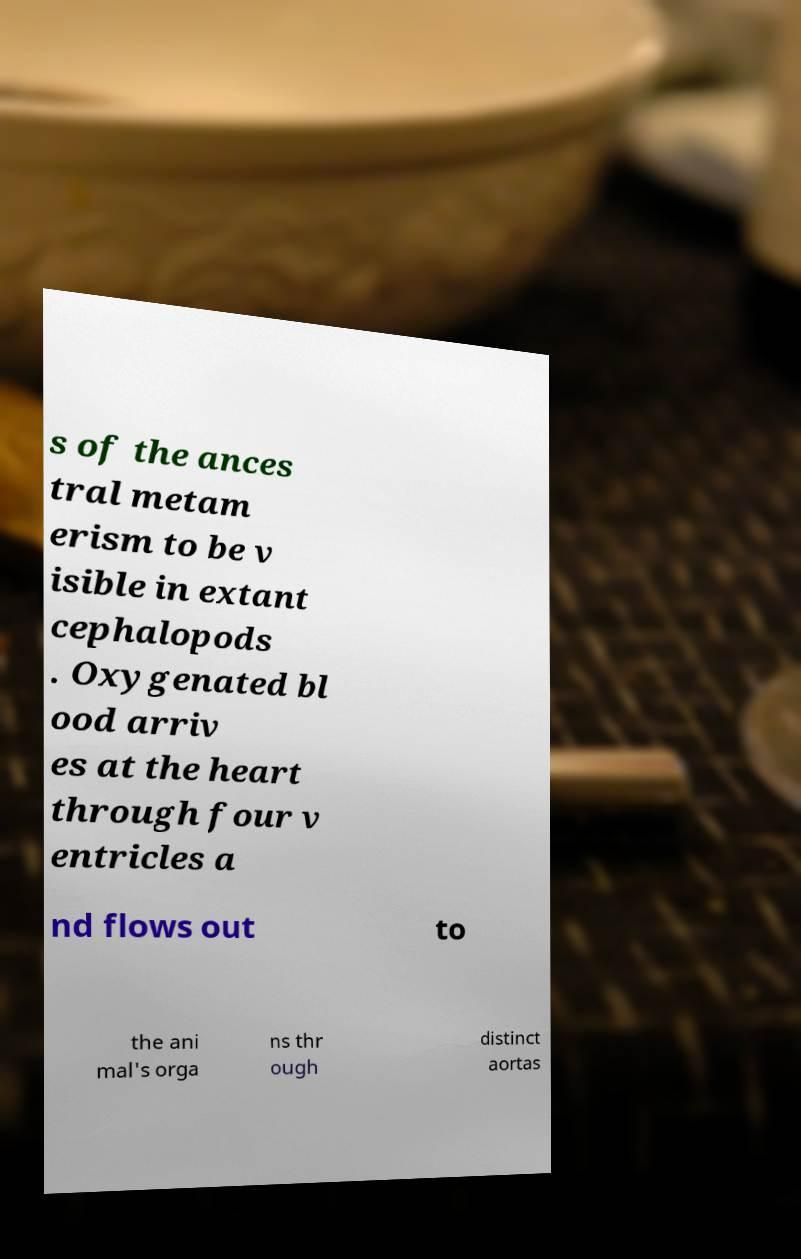Can you read and provide the text displayed in the image?This photo seems to have some interesting text. Can you extract and type it out for me? s of the ances tral metam erism to be v isible in extant cephalopods . Oxygenated bl ood arriv es at the heart through four v entricles a nd flows out to the ani mal's orga ns thr ough distinct aortas 